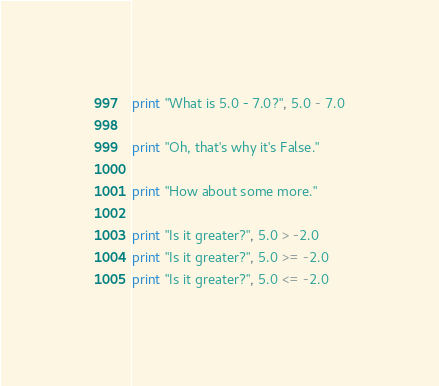Convert code to text. <code><loc_0><loc_0><loc_500><loc_500><_Python_>print "What is 5.0 - 7.0?", 5.0 - 7.0

print "Oh, that's why it's False."

print "How about some more."

print "Is it greater?", 5.0 > -2.0
print "Is it greater?", 5.0 >= -2.0
print "Is it greater?", 5.0 <= -2.0</code> 